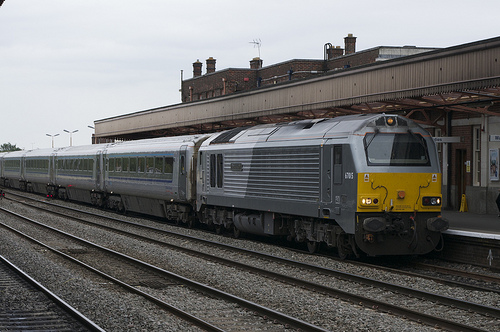What are the weather conditions depicted in the image, and how might they affect rail operations? The image depicts overcast weather with visible cloud cover, suggesting a cool or potentially rainy environment. Such conditions can affect rail operations by increasing the risk of slippery tracks and necessitating the use of lights and wipers for visibility. 